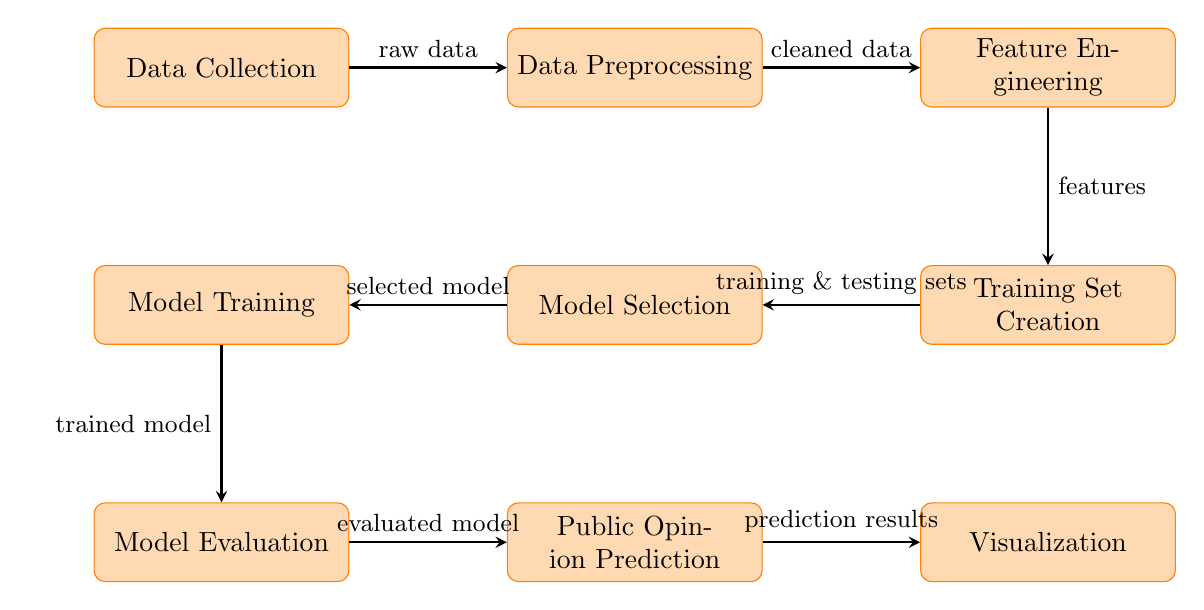What is the first step in the diagram? The diagram starts with the node labeled "Data Collection," indicating that this is the initial phase of the process.
Answer: Data Collection How many nodes are present in the diagram? By counting all the individual labeled processes in the diagram, we find there are eight nodes, including Data Collection, Data Preprocessing, Feature Engineering, Training Set Creation, Model Selection, Model Training, Model Evaluation, Public Opinion Prediction, and Visualization.
Answer: Eight What type of data is produced by the Data Preprocessing step? The arrow from Data Preprocessing to Feature Engineering is labeled "cleaned data," indicating that the output from Data Preprocessing is specifically cleaned data.
Answer: Cleaned data Which step comes after Model Training? Following the flow of arrows, the process after Model Training is Model Evaluation, indicating that model training is evaluated next.
Answer: Model Evaluation What does the Prediction node produce? The arrow leading from the Model Evaluation node to the Prediction node is labeled "evaluated model," indicating that the prediction step takes the evaluated model and produces prediction results.
Answer: Prediction results How many flow arrows are there in total? By counting the arrows that connect each node, there are a total of seven arrows showing the flow of the process from data collection to visualization.
Answer: Seven What step does Public Opinion Prediction follow? The node for Public Opinion Prediction is followed by the Visualization node, indicating that after making predictions, the next step is visualization of those results.
Answer: Visualization Which node represents the creation of training and testing sets? The Training Set Creation node is where the training and testing sets are created, as indicated by the arrow pointing from Feature Engineering to this node.
Answer: Training Set Creation What is the relationship between Feature Engineering and Training Set Creation? The arrow connecting Feature Engineering and Training Set Creation indicates that the features extracted from Feature Engineering are used as input to create the training and testing sets.
Answer: Features are used to create sets 